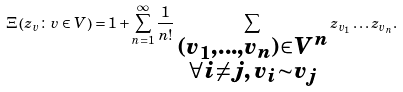<formula> <loc_0><loc_0><loc_500><loc_500>\Xi \left ( z _ { v } \colon { v \in V } \right ) = 1 + \sum _ { n = 1 } ^ { \infty } \frac { 1 } { n ! } \sum _ { \substack { ( v _ { 1 } , \dots , v _ { n } ) \in V ^ { n } \\ \forall i \neq j , \, v _ { i } \sim v _ { j } } } z _ { v _ { 1 } } \dots z _ { v _ { n } } .</formula> 